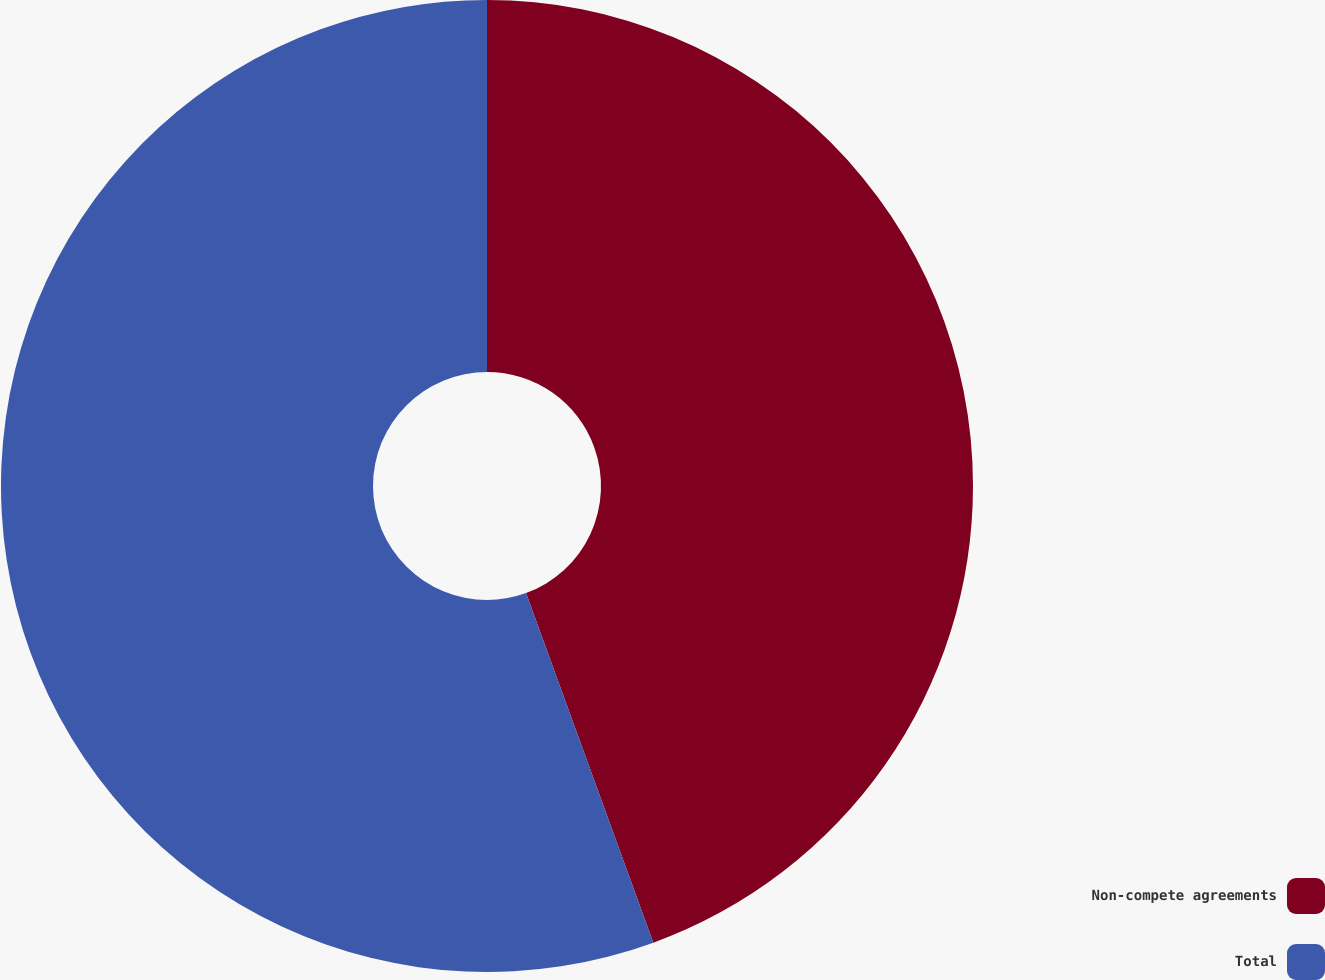<chart> <loc_0><loc_0><loc_500><loc_500><pie_chart><fcel>Non-compete agreements<fcel>Total<nl><fcel>44.44%<fcel>55.56%<nl></chart> 